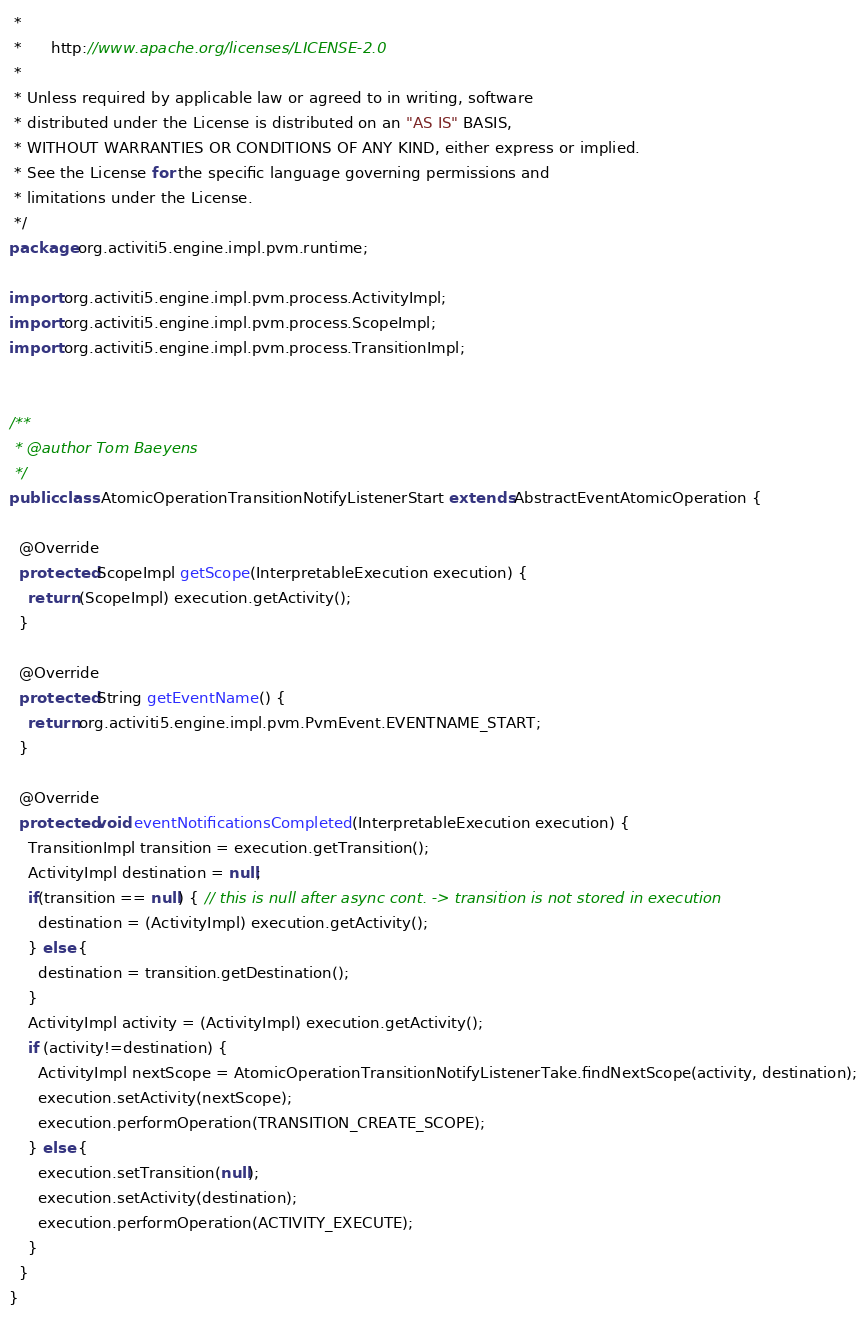Convert code to text. <code><loc_0><loc_0><loc_500><loc_500><_Java_> * 
 *      http://www.apache.org/licenses/LICENSE-2.0
 * 
 * Unless required by applicable law or agreed to in writing, software
 * distributed under the License is distributed on an "AS IS" BASIS,
 * WITHOUT WARRANTIES OR CONDITIONS OF ANY KIND, either express or implied.
 * See the License for the specific language governing permissions and
 * limitations under the License.
 */
package org.activiti5.engine.impl.pvm.runtime;

import org.activiti5.engine.impl.pvm.process.ActivityImpl;
import org.activiti5.engine.impl.pvm.process.ScopeImpl;
import org.activiti5.engine.impl.pvm.process.TransitionImpl;


/**
 * @author Tom Baeyens
 */
public class AtomicOperationTransitionNotifyListenerStart extends AbstractEventAtomicOperation {
  
  @Override
  protected ScopeImpl getScope(InterpretableExecution execution) {
    return (ScopeImpl) execution.getActivity();
  }

  @Override
  protected String getEventName() {
    return org.activiti5.engine.impl.pvm.PvmEvent.EVENTNAME_START;
  }

  @Override
  protected void eventNotificationsCompleted(InterpretableExecution execution) {
    TransitionImpl transition = execution.getTransition();
    ActivityImpl destination = null;
    if(transition == null) { // this is null after async cont. -> transition is not stored in execution
      destination = (ActivityImpl) execution.getActivity();
    } else {
      destination = transition.getDestination();
    }    
    ActivityImpl activity = (ActivityImpl) execution.getActivity();
    if (activity!=destination) {
      ActivityImpl nextScope = AtomicOperationTransitionNotifyListenerTake.findNextScope(activity, destination);
      execution.setActivity(nextScope);
      execution.performOperation(TRANSITION_CREATE_SCOPE);
    } else {
      execution.setTransition(null);
      execution.setActivity(destination);
      execution.performOperation(ACTIVITY_EXECUTE);
    }
  }
}
</code> 